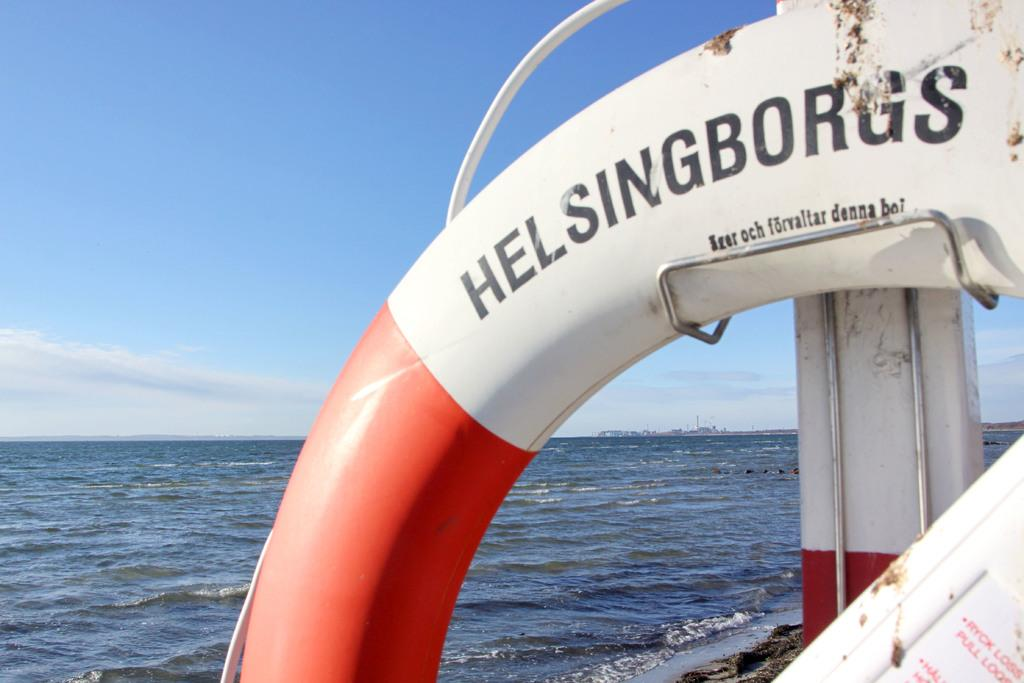<image>
Offer a succinct explanation of the picture presented. a round item with Helsingborgs written on it 